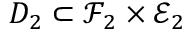<formula> <loc_0><loc_0><loc_500><loc_500>D _ { 2 } \subset \mathcal { F } _ { 2 } \times \mathcal { E } _ { 2 }</formula> 